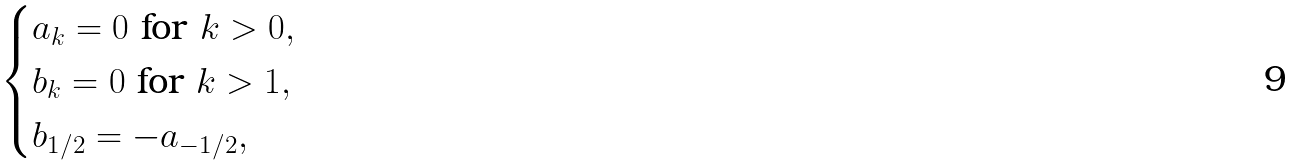Convert formula to latex. <formula><loc_0><loc_0><loc_500><loc_500>\begin{cases} a _ { k } = 0 \text { for } k > 0 , \\ b _ { k } = 0 \text { for } k > 1 , \\ b _ { 1 / 2 } = - a _ { - 1 / 2 } , \end{cases}</formula> 